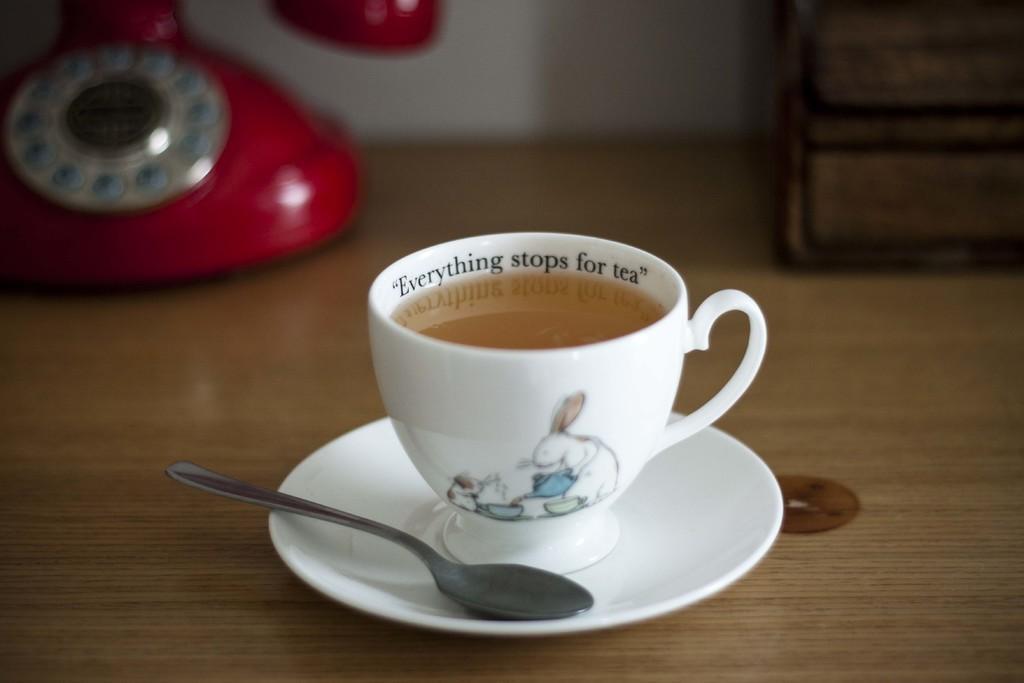In one or two sentences, can you explain what this image depicts? In this image there is a telephone and beside that there is a cup with coffee, saucer and spoon. 